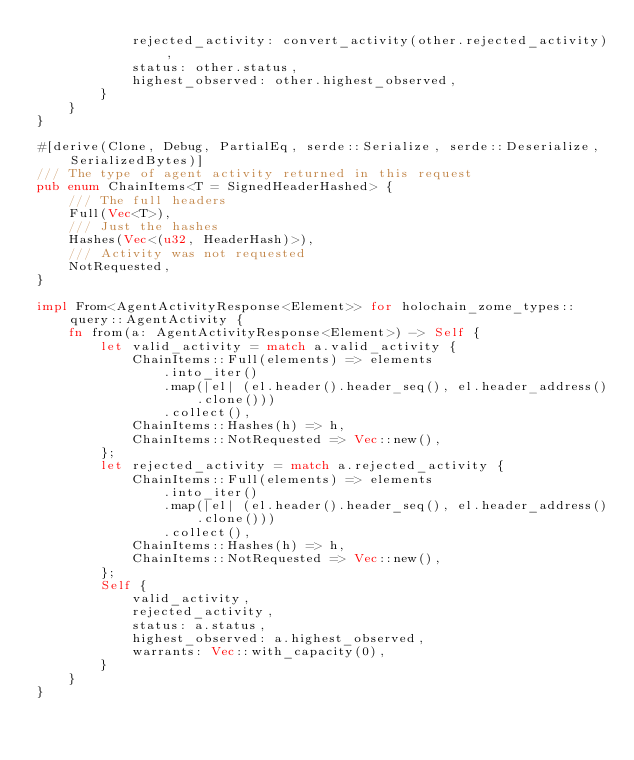<code> <loc_0><loc_0><loc_500><loc_500><_Rust_>            rejected_activity: convert_activity(other.rejected_activity),
            status: other.status,
            highest_observed: other.highest_observed,
        }
    }
}

#[derive(Clone, Debug, PartialEq, serde::Serialize, serde::Deserialize, SerializedBytes)]
/// The type of agent activity returned in this request
pub enum ChainItems<T = SignedHeaderHashed> {
    /// The full headers
    Full(Vec<T>),
    /// Just the hashes
    Hashes(Vec<(u32, HeaderHash)>),
    /// Activity was not requested
    NotRequested,
}

impl From<AgentActivityResponse<Element>> for holochain_zome_types::query::AgentActivity {
    fn from(a: AgentActivityResponse<Element>) -> Self {
        let valid_activity = match a.valid_activity {
            ChainItems::Full(elements) => elements
                .into_iter()
                .map(|el| (el.header().header_seq(), el.header_address().clone()))
                .collect(),
            ChainItems::Hashes(h) => h,
            ChainItems::NotRequested => Vec::new(),
        };
        let rejected_activity = match a.rejected_activity {
            ChainItems::Full(elements) => elements
                .into_iter()
                .map(|el| (el.header().header_seq(), el.header_address().clone()))
                .collect(),
            ChainItems::Hashes(h) => h,
            ChainItems::NotRequested => Vec::new(),
        };
        Self {
            valid_activity,
            rejected_activity,
            status: a.status,
            highest_observed: a.highest_observed,
            warrants: Vec::with_capacity(0),
        }
    }
}
</code> 